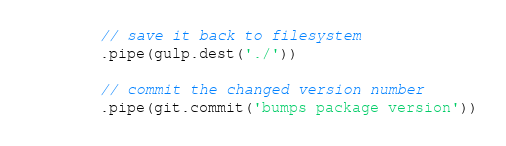<code> <loc_0><loc_0><loc_500><loc_500><_JavaScript_>
        // save it back to filesystem
        .pipe(gulp.dest('./'))

        // commit the changed version number
        .pipe(git.commit('bumps package version'))
</code> 